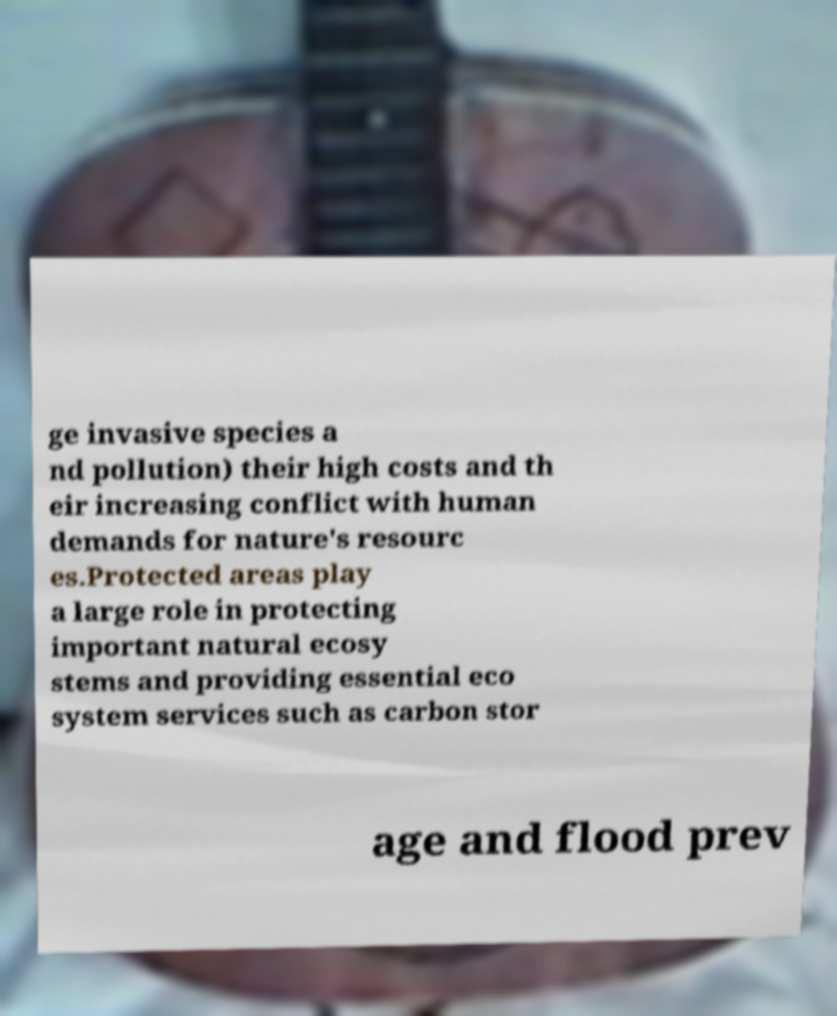Could you assist in decoding the text presented in this image and type it out clearly? ge invasive species a nd pollution) their high costs and th eir increasing conflict with human demands for nature's resourc es.Protected areas play a large role in protecting important natural ecosy stems and providing essential eco system services such as carbon stor age and flood prev 